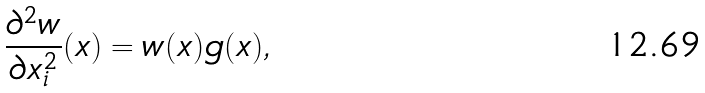<formula> <loc_0><loc_0><loc_500><loc_500>\frac { \partial ^ { 2 } w } { \partial x _ { i } ^ { 2 } } ( x ) = w ( x ) g ( x ) ,</formula> 